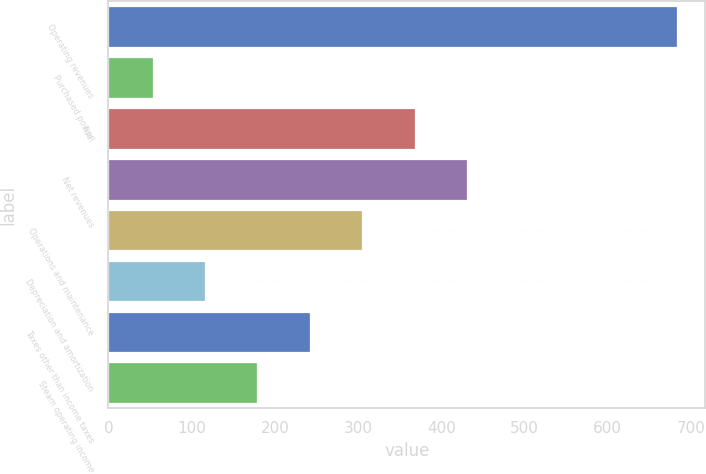Convert chart. <chart><loc_0><loc_0><loc_500><loc_500><bar_chart><fcel>Operating revenues<fcel>Purchased power<fcel>Fuel<fcel>Net revenues<fcel>Operations and maintenance<fcel>Depreciation and amortization<fcel>Taxes other than income taxes<fcel>Steam operating income<nl><fcel>683<fcel>53<fcel>368<fcel>431<fcel>305<fcel>116<fcel>242<fcel>179<nl></chart> 